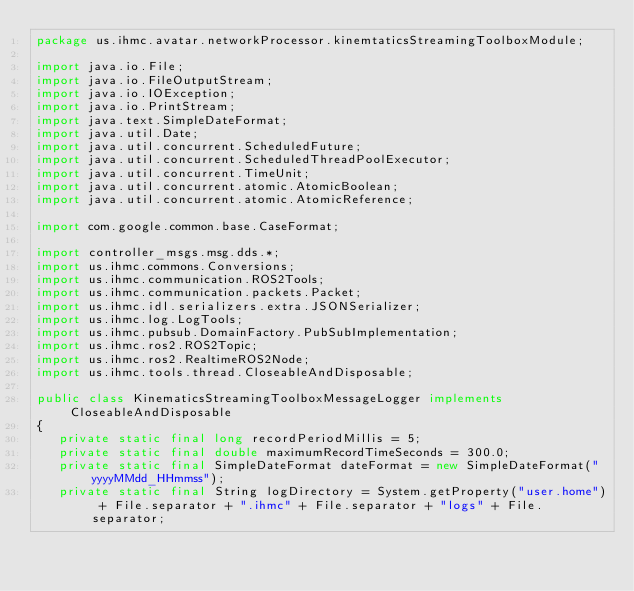<code> <loc_0><loc_0><loc_500><loc_500><_Java_>package us.ihmc.avatar.networkProcessor.kinemtaticsStreamingToolboxModule;

import java.io.File;
import java.io.FileOutputStream;
import java.io.IOException;
import java.io.PrintStream;
import java.text.SimpleDateFormat;
import java.util.Date;
import java.util.concurrent.ScheduledFuture;
import java.util.concurrent.ScheduledThreadPoolExecutor;
import java.util.concurrent.TimeUnit;
import java.util.concurrent.atomic.AtomicBoolean;
import java.util.concurrent.atomic.AtomicReference;

import com.google.common.base.CaseFormat;

import controller_msgs.msg.dds.*;
import us.ihmc.commons.Conversions;
import us.ihmc.communication.ROS2Tools;
import us.ihmc.communication.packets.Packet;
import us.ihmc.idl.serializers.extra.JSONSerializer;
import us.ihmc.log.LogTools;
import us.ihmc.pubsub.DomainFactory.PubSubImplementation;
import us.ihmc.ros2.ROS2Topic;
import us.ihmc.ros2.RealtimeROS2Node;
import us.ihmc.tools.thread.CloseableAndDisposable;

public class KinematicsStreamingToolboxMessageLogger implements CloseableAndDisposable
{
   private static final long recordPeriodMillis = 5;
   private static final double maximumRecordTimeSeconds = 300.0;
   private static final SimpleDateFormat dateFormat = new SimpleDateFormat("yyyyMMdd_HHmmss");
   private static final String logDirectory = System.getProperty("user.home") + File.separator + ".ihmc" + File.separator + "logs" + File.separator;
</code> 